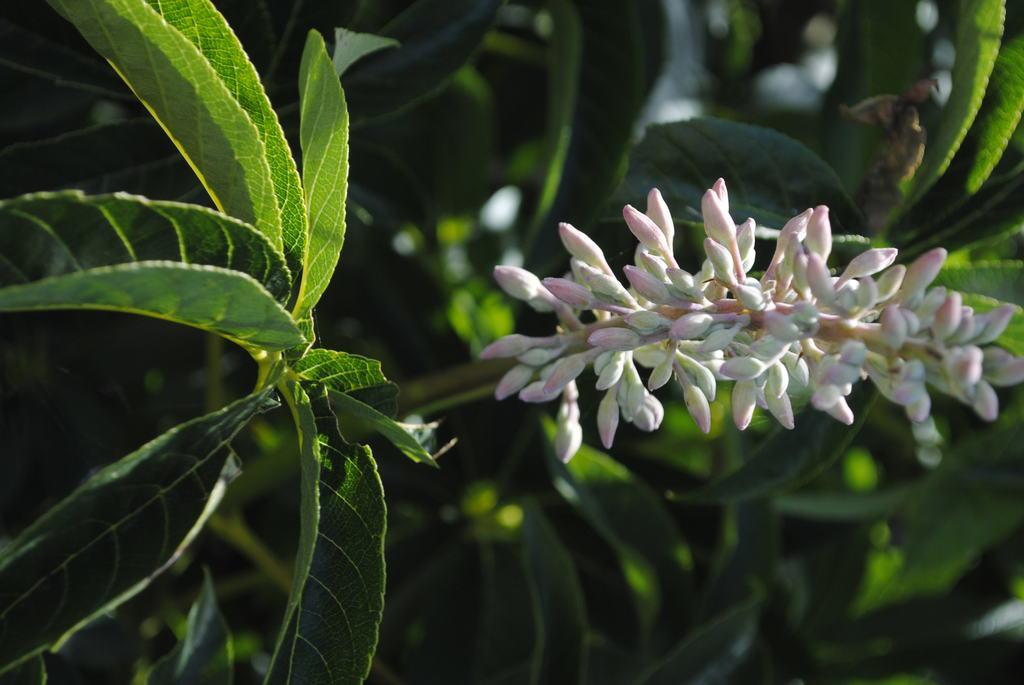Please provide a concise description of this image. This image is taken in outdoors. In this image there is a tree with green leaves and plants. 